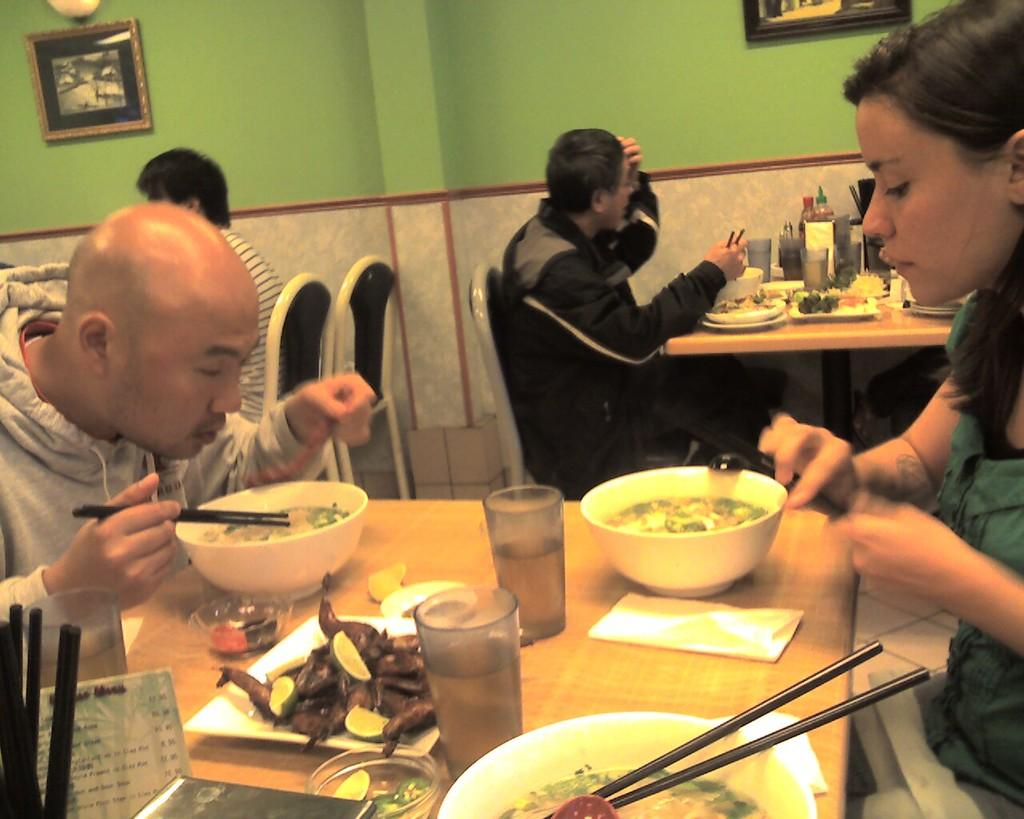How many people are in the image? There is a group of people in the image. What are the people doing in the image? The people are sitting on chairs. What is on the table in the image? There is a glass, a bowl, a stick, and a tissue on the table. What can be seen in the background of the image? In the background, there is a photo frame. What shape is the calendar on the table in the image? There is no calendar present in the image. What type of liquid is in the glass on the table in the image? The contents of the glass cannot be determined from the image, as it is not specified. 